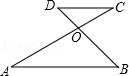Articulate your interpretation of the image. The image depicts a geometric drawing with two pairs of parallel lines, AB and CD, intersecting with two other lines, AC and BD, at point O. This setup is typical in discussions of properties such as the angles formed at the intersection and their relationships, possibly illustrating concepts like corresponding angles or the converse of the alternate interior angles theorem. Observing such a configuration might help in proving certain properties of parallel lines or in applications like construction and design where precise angles are required. 